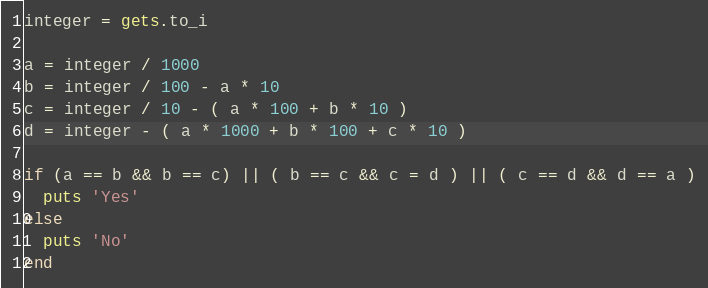Convert code to text. <code><loc_0><loc_0><loc_500><loc_500><_Ruby_>integer = gets.to_i

a = integer / 1000
b = integer / 100 - a * 10
c = integer / 10 - ( a * 100 + b * 10 )
d = integer - ( a * 1000 + b * 100 + c * 10 )

if (a == b && b == c) || ( b == c && c = d ) || ( c == d && d == a )
  puts 'Yes'
else
  puts 'No'
end
</code> 